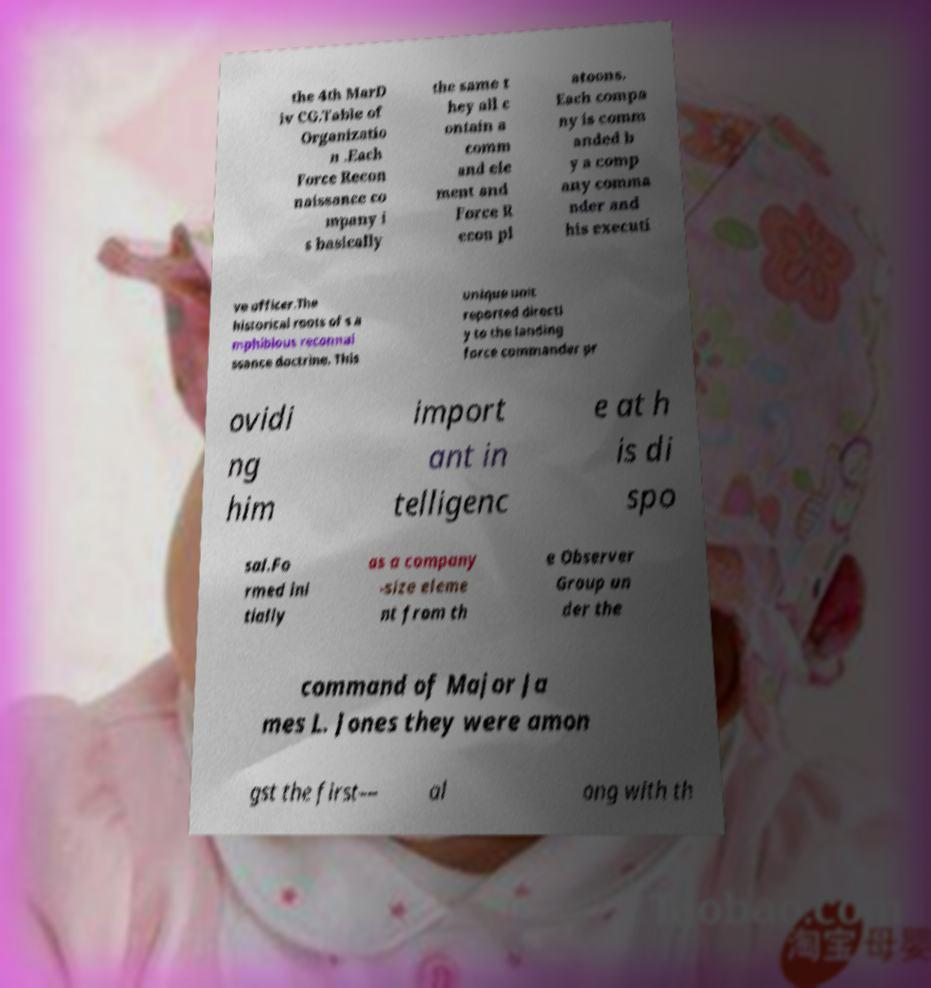I need the written content from this picture converted into text. Can you do that? the 4th MarD iv CG.Table of Organizatio n .Each Force Recon naissance co mpany i s basically the same t hey all c ontain a comm and ele ment and Force R econ pl atoons. Each compa ny is comm anded b y a comp any comma nder and his executi ve officer.The historical roots of s a mphibious reconnai ssance doctrine. This unique unit reported directl y to the landing force commander pr ovidi ng him import ant in telligenc e at h is di spo sal.Fo rmed ini tially as a company -size eleme nt from th e Observer Group un der the command of Major Ja mes L. Jones they were amon gst the first— al ong with th 